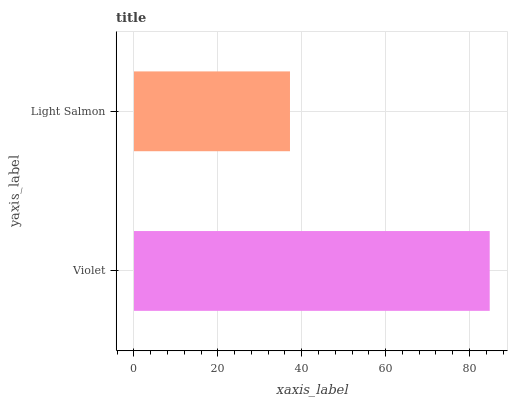Is Light Salmon the minimum?
Answer yes or no. Yes. Is Violet the maximum?
Answer yes or no. Yes. Is Light Salmon the maximum?
Answer yes or no. No. Is Violet greater than Light Salmon?
Answer yes or no. Yes. Is Light Salmon less than Violet?
Answer yes or no. Yes. Is Light Salmon greater than Violet?
Answer yes or no. No. Is Violet less than Light Salmon?
Answer yes or no. No. Is Violet the high median?
Answer yes or no. Yes. Is Light Salmon the low median?
Answer yes or no. Yes. Is Light Salmon the high median?
Answer yes or no. No. Is Violet the low median?
Answer yes or no. No. 